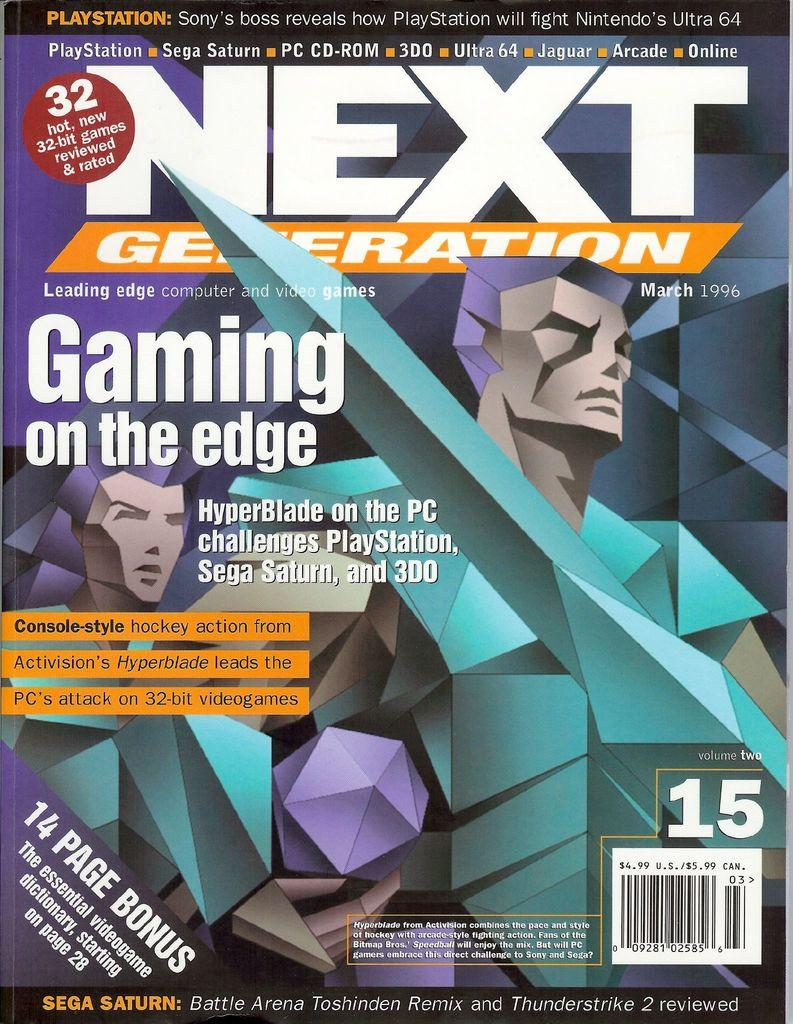<image>
Render a clear and concise summary of the photo. Next Generation magazine cover dated from March 1996. 